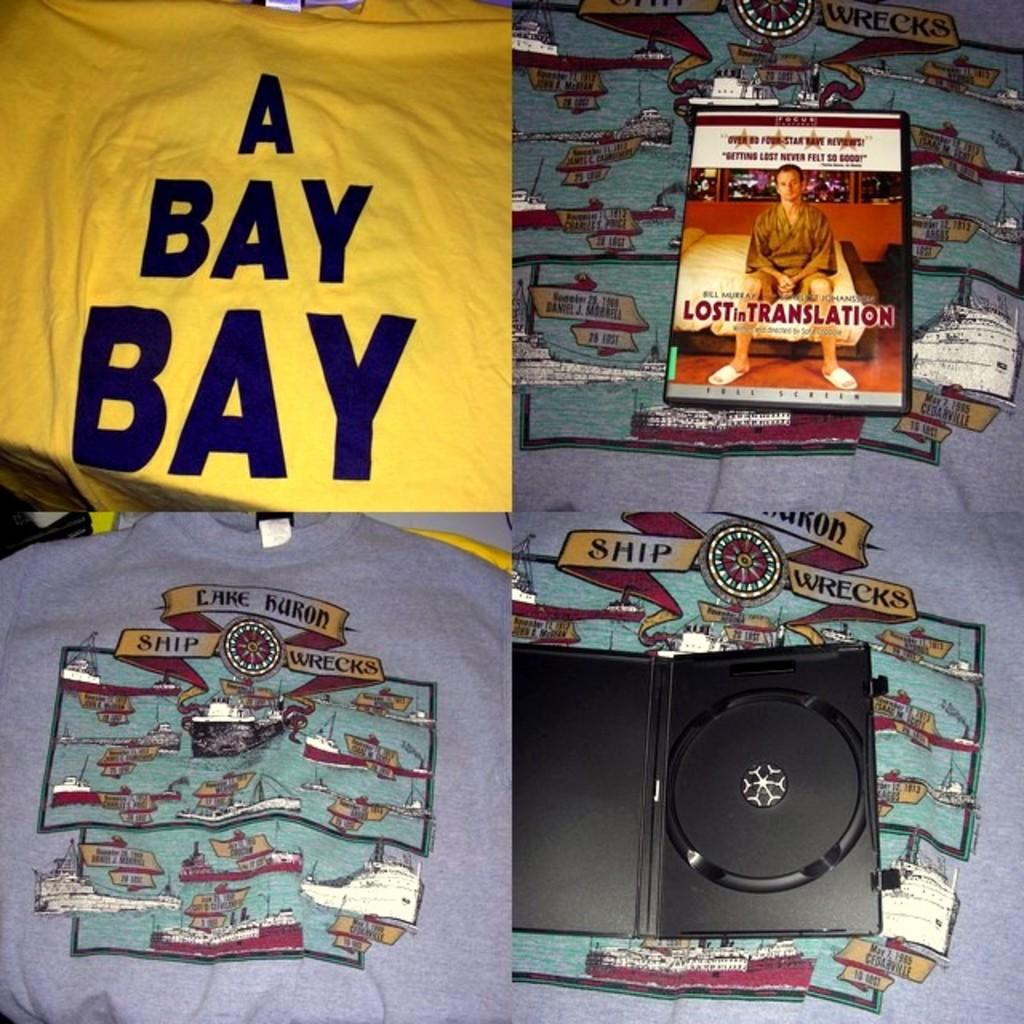<image>
Create a compact narrative representing the image presented. lost in translation dvd on a table with a shirt saying bay bay bay 